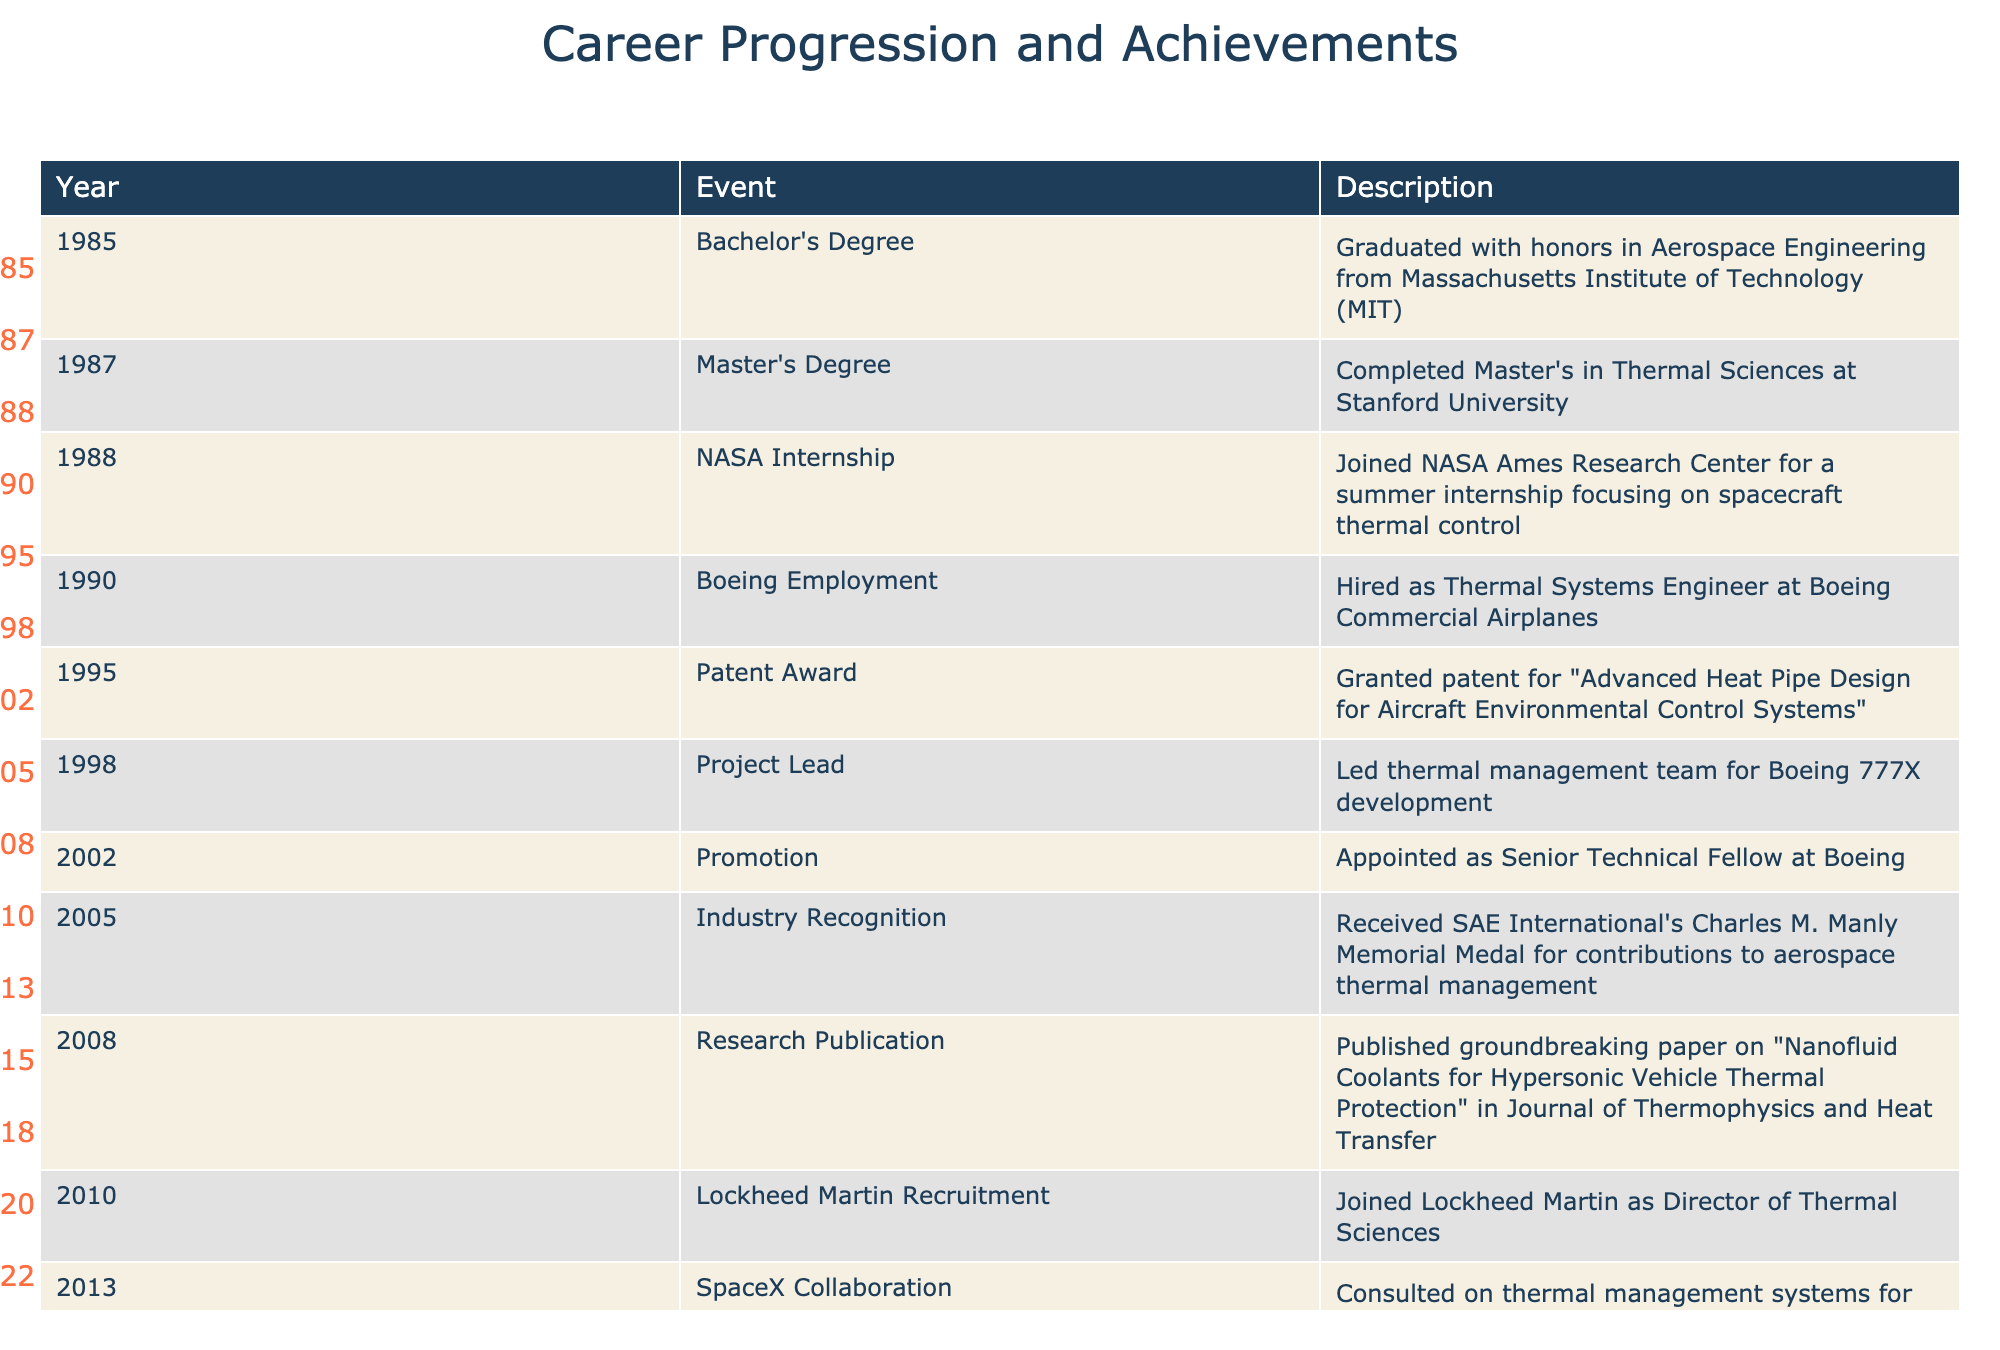What year did the thermal engineer graduate with a Bachelor's Degree? The table indicates that the individual graduated with a Bachelor's Degree in Aerospace Engineering in the year 1985.
Answer: 1985 In which year was the first major patent awarded? The table lists the Patent Award event in the year 1995, which corresponds to the first major patent granted to this engineer.
Answer: 1995 How many years was the engineer employed at Boeing before joining Lockheed Martin? The engineer started at Boeing in 1990 and joined Lockheed Martin in 2010. Therefore, the duration of employment at Boeing is 2010 - 1990 = 20 years.
Answer: 20 years Did the thermal engineer publish a research paper before becoming a Director at Lockheed Martin? According to the table, the engineer published a research paper in 2008 and joined Lockheed Martin in 2010, confirming that the paper was published before the directorship.
Answer: Yes What is the total number of significant achievements listed from 2005 to 2018? During the years from 2005 (Industry Recognition) to 2018 (NASA Contract), the significant achievements include four events: Industry Recognition (2005), Research Publication (2008), AIAA Fellow (2015), and NASA Contract (2018). Thus, the total is 4.
Answer: 4 In what years did the thermal engineer receive awards from the AIAA? The table shows that the thermal engineer received the AIAA Thermophysics Award in 2022 and was elected as Fellow of the AIAA in 2015. Therefore, the years are 2015 and 2022.
Answer: 2015 and 2022 What major project did the engineer lead in 1998, and how does it contribute to modern aircraft? In 1998, the engineer led the thermal management team for the Boeing 777X development, which is significant as it integrates advanced thermal management solutions, enhancing performance and safety in modern aircraft. This requires integrating multiple aspects of thermal control and demonstrates the engineer's leadership in thermal technology.
Answer: Boeing 777X What is the difference in years between the engineer's Bachelor's and Master's degrees? The engineer obtained a Bachelor’s Degree in 1985 and a Master’s Degree in 1987, resulting in a difference of 1987 - 1985 = 2 years between the two degrees.
Answer: 2 years 